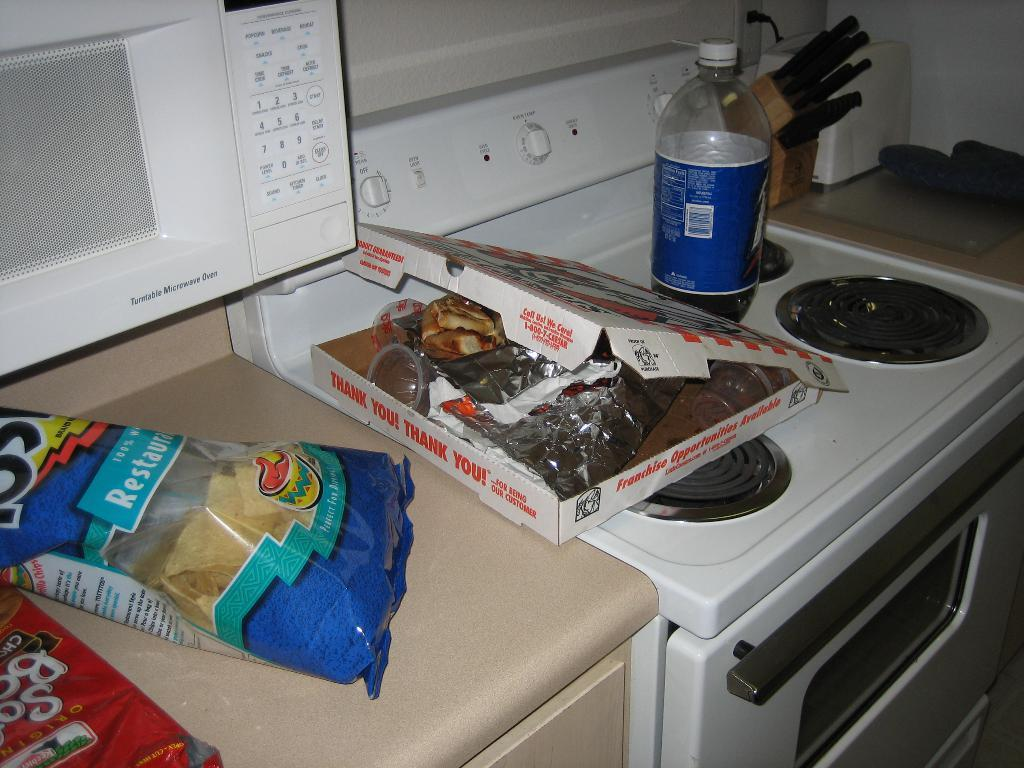<image>
Offer a succinct explanation of the picture presented. A bag of tostitos next to an empty pizza box and 2 liter bottle of soda on a stove 